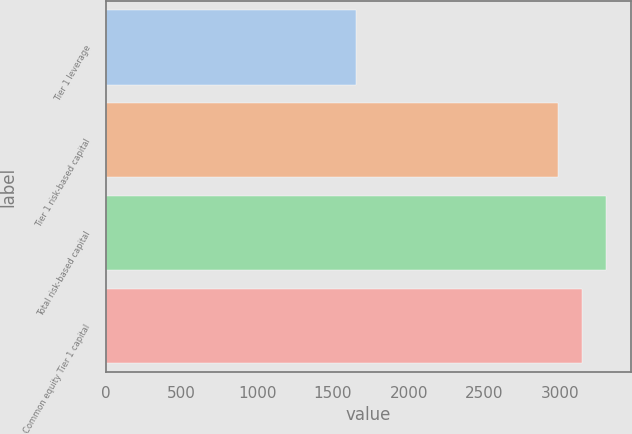Convert chart to OTSL. <chart><loc_0><loc_0><loc_500><loc_500><bar_chart><fcel>Tier 1 leverage<fcel>Tier 1 risk-based capital<fcel>Total risk-based capital<fcel>Common equity Tier 1 capital<nl><fcel>1654<fcel>2984<fcel>3299.6<fcel>3141.8<nl></chart> 